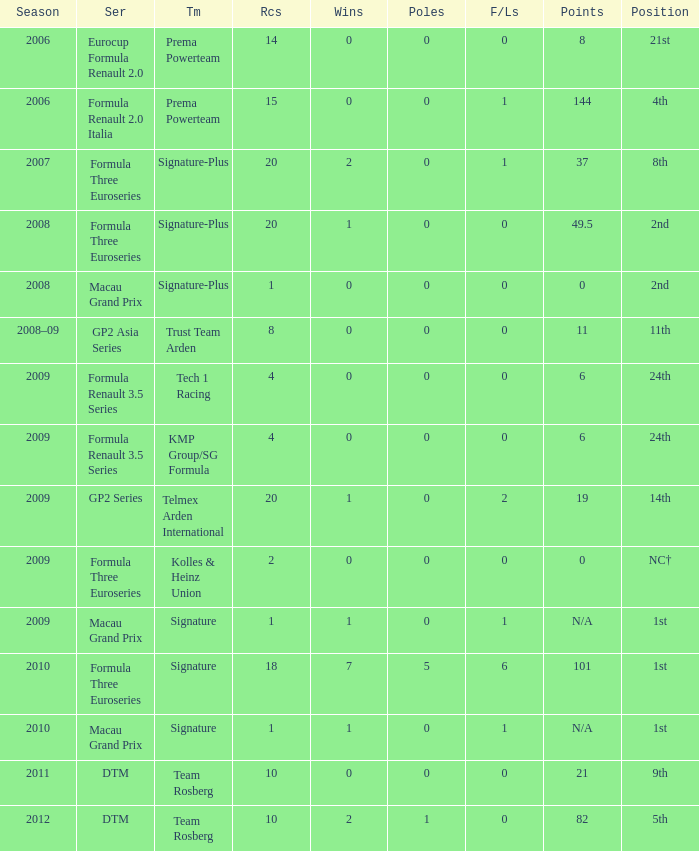How many races did the Formula Three Euroseries signature team have? 18.0. 